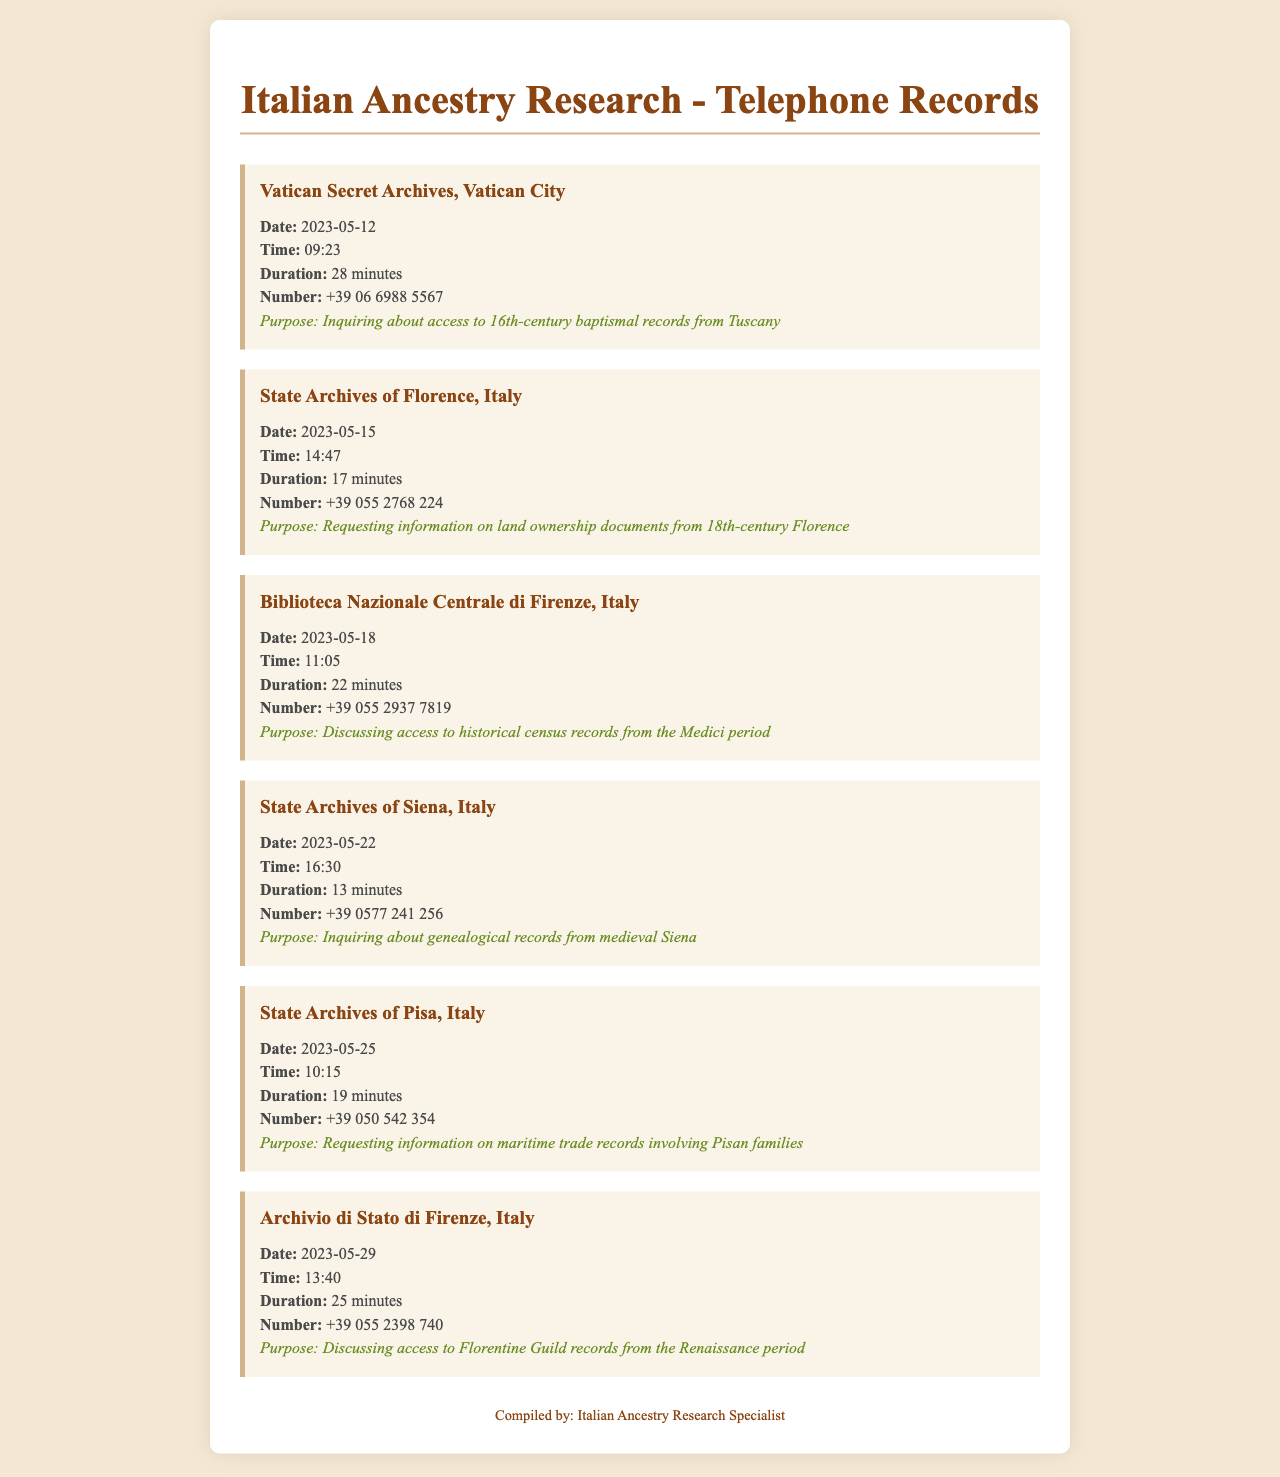What was the purpose of the call to the Vatican Secret Archives? The purpose of the call was to inquire about access to 16th-century baptismal records from Tuscany.
Answer: Inquiring about access to 16th-century baptismal records from Tuscany What is the phone number for the State Archives of Florence? The phone number listed for the State Archives of Florence is +39 055 2768 224.
Answer: +39 055 2768 224 How long did the call to Biblioteca Nazionale Centrale di Firenze last? The call lasted for 22 minutes as indicated in the document.
Answer: 22 minutes On what date was the call to the State Archives of Siena made? The call to the State Archives of Siena was made on 2023-05-22.
Answer: 2023-05-22 Which archive was contacted regarding maritime trade records? The State Archives of Pisa was contacted for information on maritime trade records involving Pisan families.
Answer: State Archives of Pisa What can be inferred about the significance of the calls made to various archives? The calls indicate a meticulous research effort focused on accessing historical and genealogical records pertaining to family ancestry.
Answer: Research effort focused on accessing historical and genealogical records What is a common theme of the purposes for these calls? The common theme is the inquiry about historical documents relevant to genealogical research.
Answer: Inquiry about historical documents relevant to genealogical research How many calls were made to archives in total? There were six calls made to various archives as documented.
Answer: Six calls When was the last recorded call in the document? The last recorded call was made on 2023-05-29.
Answer: 2023-05-29 